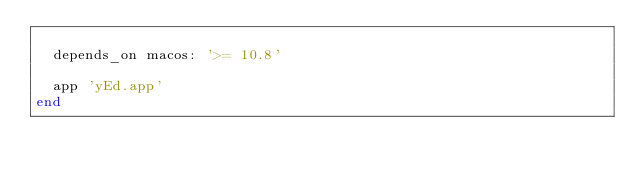Convert code to text. <code><loc_0><loc_0><loc_500><loc_500><_Ruby_>
  depends_on macos: '>= 10.8'

  app 'yEd.app'
end
</code> 